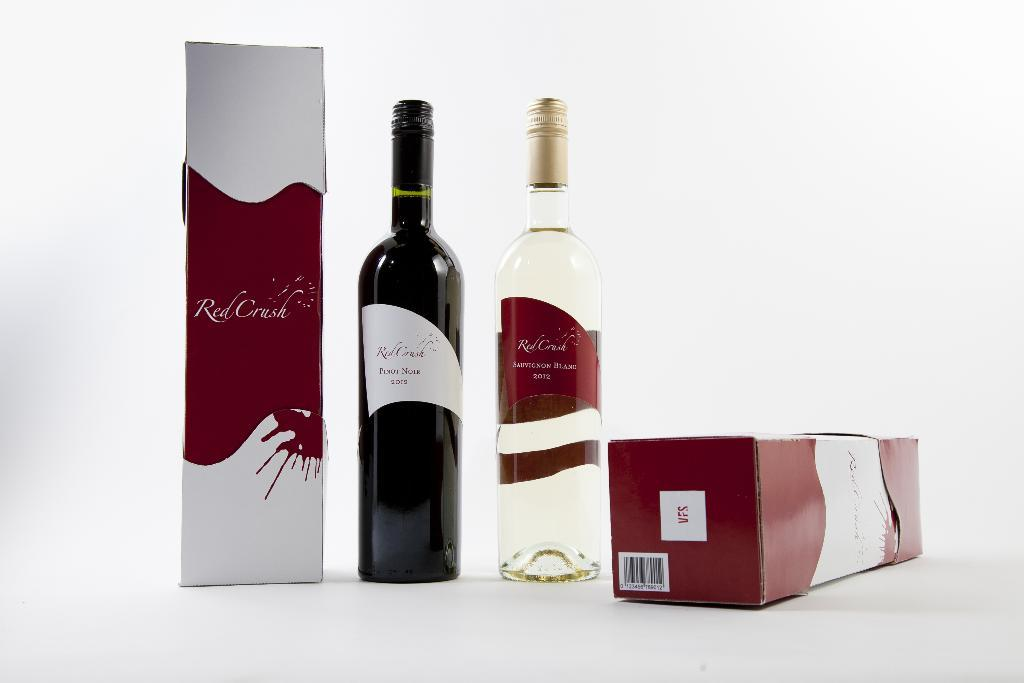<image>
Relay a brief, clear account of the picture shown. Bottles and boxes of Red Crush brand wine sit on a white surface. 